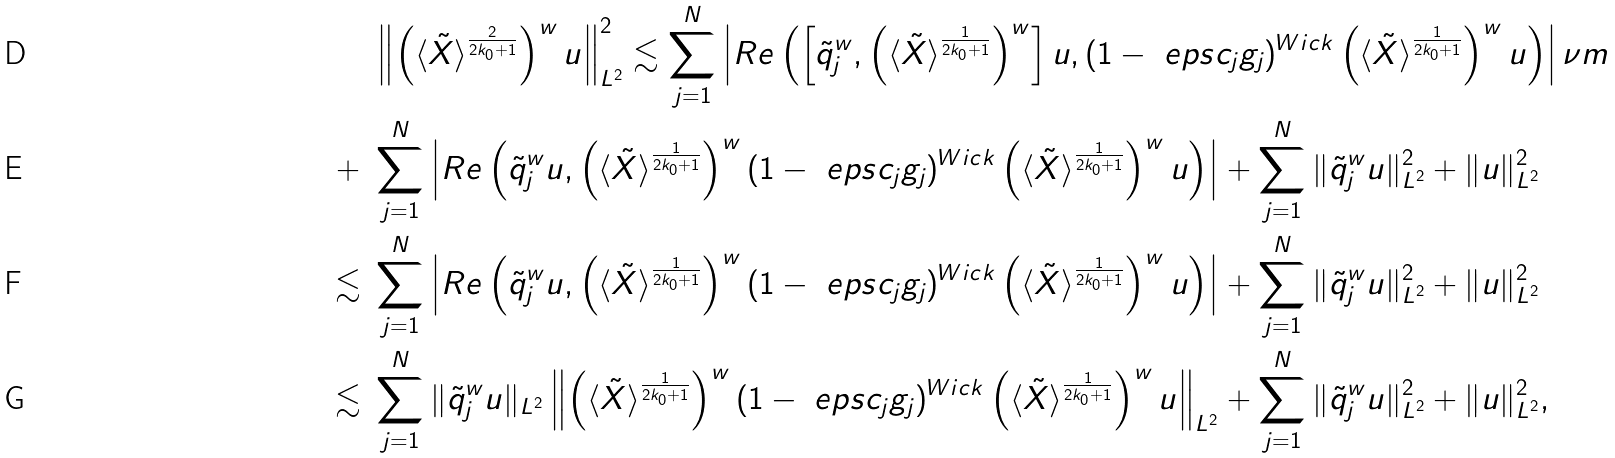<formula> <loc_0><loc_0><loc_500><loc_500>& \ \left \| \left ( \langle \tilde { X } \rangle ^ { \frac { 2 } { 2 k _ { 0 } + 1 } } \right ) ^ { w } u \right \| _ { L ^ { 2 } } ^ { 2 } \lesssim \sum _ { j = 1 } ^ { N } \left | R e \left ( \left [ \tilde { q } _ { j } ^ { w } , \left ( \langle \tilde { X } \rangle ^ { \frac { 1 } { 2 k _ { 0 } + 1 } } \right ) ^ { w } \right ] u , ( 1 - \ e p s c _ { j } g _ { j } ) ^ { W i c k } \left ( \langle \tilde { X } \rangle ^ { \frac { 1 } { 2 k _ { 0 } + 1 } } \right ) ^ { w } u \right ) \right | \nu m \\ + & \ \sum _ { j = 1 } ^ { N } \left | R e \left ( \tilde { q } _ { j } ^ { w } u , \left ( \langle \tilde { X } \rangle ^ { \frac { 1 } { 2 k _ { 0 } + 1 } } \right ) ^ { w } ( 1 - \ e p s c _ { j } g _ { j } ) ^ { W i c k } \left ( \langle \tilde { X } \rangle ^ { \frac { 1 } { 2 k _ { 0 } + 1 } } \right ) ^ { w } u \right ) \right | + \sum _ { j = 1 } ^ { N } \| \tilde { q } _ { j } ^ { w } u \| _ { L ^ { 2 } } ^ { 2 } + \| u \| _ { L ^ { 2 } } ^ { 2 } \\ \lesssim & \ \sum _ { j = 1 } ^ { N } \left | R e \left ( \tilde { q } _ { j } ^ { w } u , \left ( \langle \tilde { X } \rangle ^ { \frac { 1 } { 2 k _ { 0 } + 1 } } \right ) ^ { w } ( 1 - \ e p s c _ { j } g _ { j } ) ^ { W i c k } \left ( \langle \tilde { X } \rangle ^ { \frac { 1 } { 2 k _ { 0 } + 1 } } \right ) ^ { w } u \right ) \right | + \sum _ { j = 1 } ^ { N } \| \tilde { q } _ { j } ^ { w } u \| _ { L ^ { 2 } } ^ { 2 } + \| u \| _ { L ^ { 2 } } ^ { 2 } \\ \lesssim & \ \sum _ { j = 1 } ^ { N } \| \tilde { q } _ { j } ^ { w } u \| _ { L ^ { 2 } } \left \| \left ( \langle \tilde { X } \rangle ^ { \frac { 1 } { 2 k _ { 0 } + 1 } } \right ) ^ { w } ( 1 - \ e p s c _ { j } g _ { j } ) ^ { W i c k } \left ( \langle \tilde { X } \rangle ^ { \frac { 1 } { 2 k _ { 0 } + 1 } } \right ) ^ { w } u \right \| _ { L ^ { 2 } } + \sum _ { j = 1 } ^ { N } \| \tilde { q } _ { j } ^ { w } u \| _ { L ^ { 2 } } ^ { 2 } + \| u \| _ { L ^ { 2 } } ^ { 2 } ,</formula> 